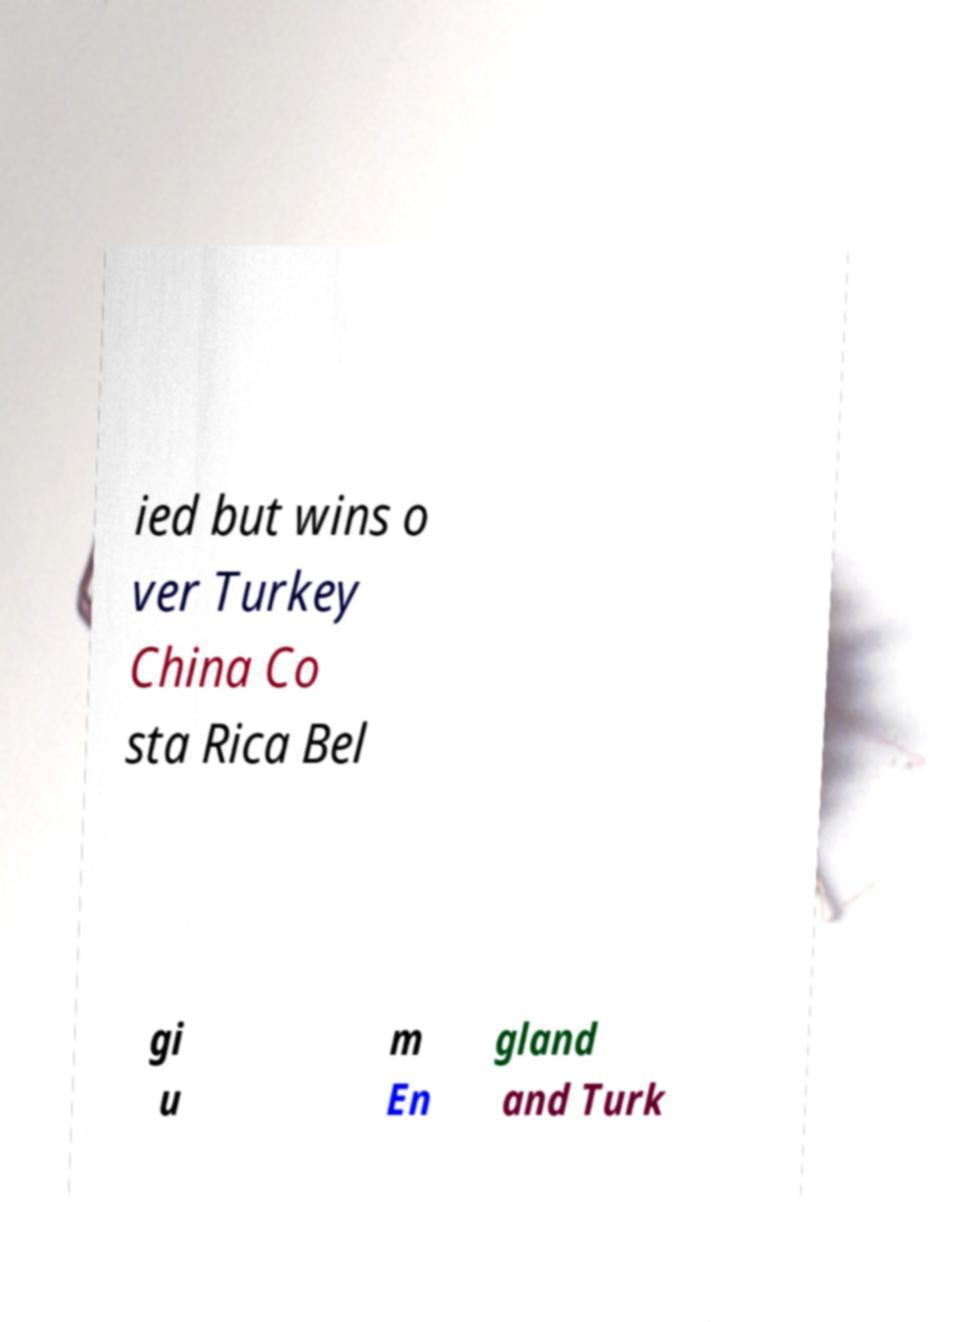Can you read and provide the text displayed in the image?This photo seems to have some interesting text. Can you extract and type it out for me? ied but wins o ver Turkey China Co sta Rica Bel gi u m En gland and Turk 